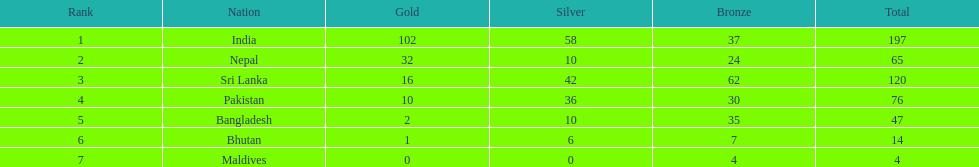What country has won no silver medals? Maldives. 